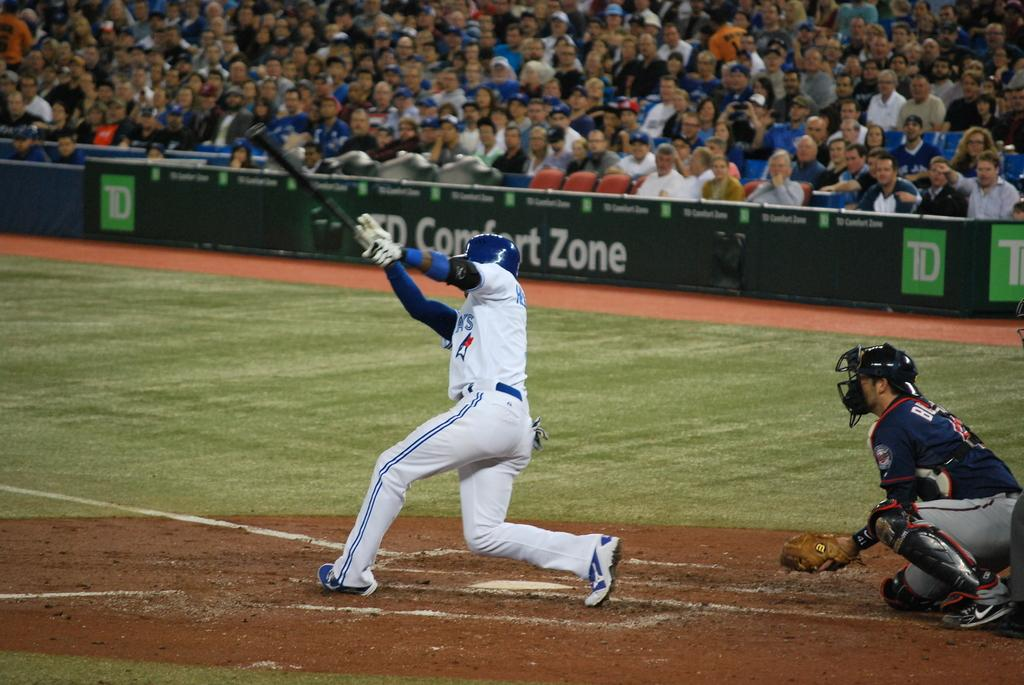Provide a one-sentence caption for the provided image. batter swinging his bat with td comfort zone signage in background. 